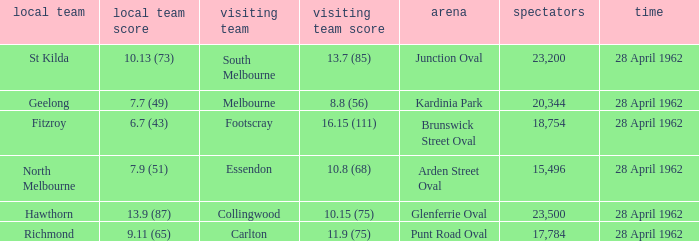What away team played at Brunswick Street Oval? Footscray. 